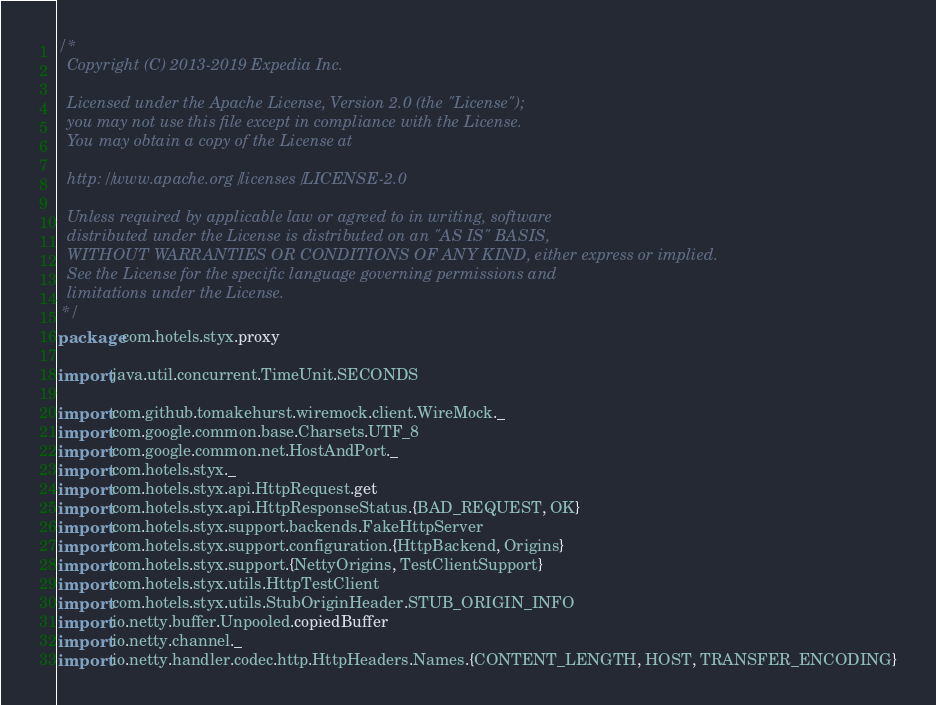<code> <loc_0><loc_0><loc_500><loc_500><_Scala_>/*
  Copyright (C) 2013-2019 Expedia Inc.

  Licensed under the Apache License, Version 2.0 (the "License");
  you may not use this file except in compliance with the License.
  You may obtain a copy of the License at

  http://www.apache.org/licenses/LICENSE-2.0

  Unless required by applicable law or agreed to in writing, software
  distributed under the License is distributed on an "AS IS" BASIS,
  WITHOUT WARRANTIES OR CONDITIONS OF ANY KIND, either express or implied.
  See the License for the specific language governing permissions and
  limitations under the License.
 */
package com.hotels.styx.proxy

import java.util.concurrent.TimeUnit.SECONDS

import com.github.tomakehurst.wiremock.client.WireMock._
import com.google.common.base.Charsets.UTF_8
import com.google.common.net.HostAndPort._
import com.hotels.styx._
import com.hotels.styx.api.HttpRequest.get
import com.hotels.styx.api.HttpResponseStatus.{BAD_REQUEST, OK}
import com.hotels.styx.support.backends.FakeHttpServer
import com.hotels.styx.support.configuration.{HttpBackend, Origins}
import com.hotels.styx.support.{NettyOrigins, TestClientSupport}
import com.hotels.styx.utils.HttpTestClient
import com.hotels.styx.utils.StubOriginHeader.STUB_ORIGIN_INFO
import io.netty.buffer.Unpooled.copiedBuffer
import io.netty.channel._
import io.netty.handler.codec.http.HttpHeaders.Names.{CONTENT_LENGTH, HOST, TRANSFER_ENCODING}</code> 